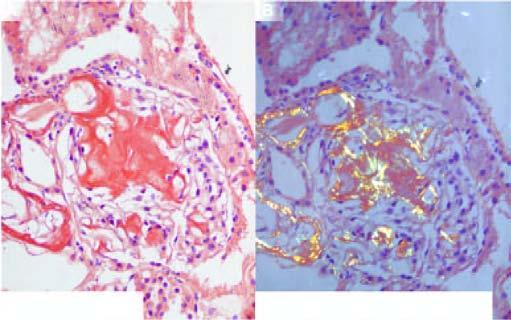what show birefringence?
Answer the question using a single word or phrase. The congophilic areas 